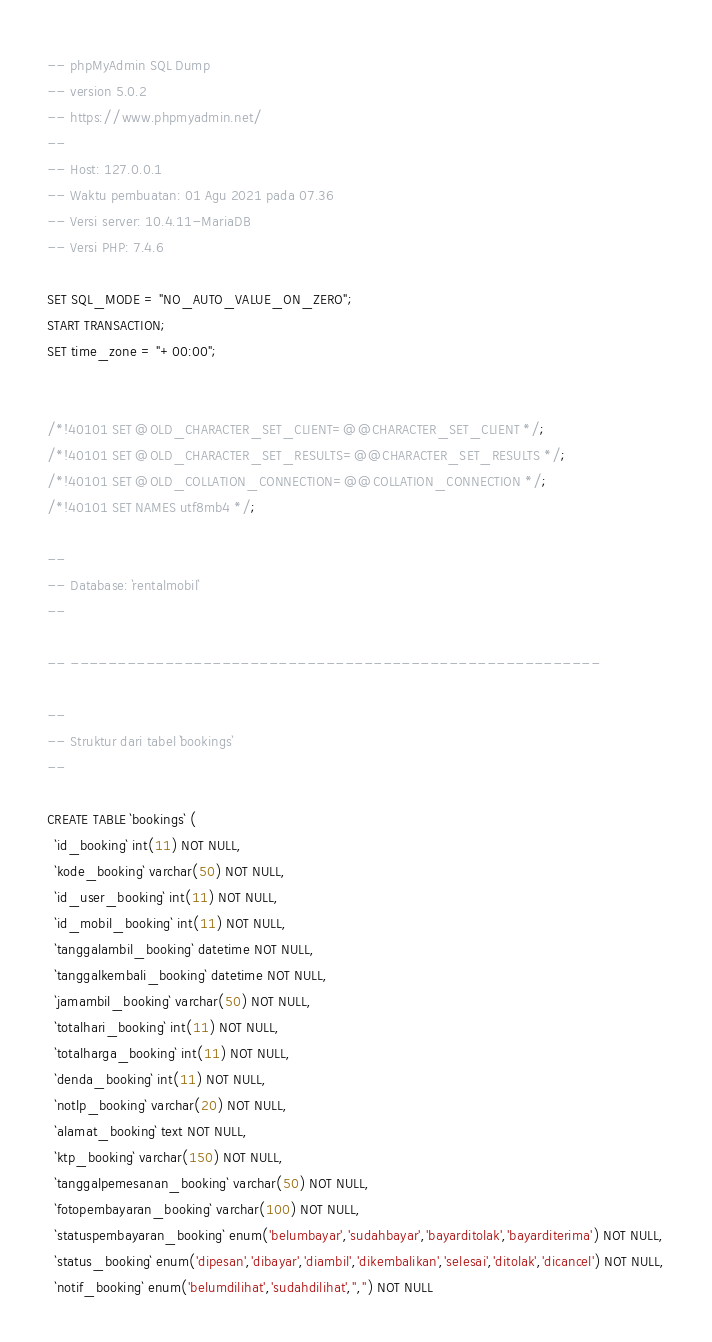Convert code to text. <code><loc_0><loc_0><loc_500><loc_500><_SQL_>-- phpMyAdmin SQL Dump
-- version 5.0.2
-- https://www.phpmyadmin.net/
--
-- Host: 127.0.0.1
-- Waktu pembuatan: 01 Agu 2021 pada 07.36
-- Versi server: 10.4.11-MariaDB
-- Versi PHP: 7.4.6

SET SQL_MODE = "NO_AUTO_VALUE_ON_ZERO";
START TRANSACTION;
SET time_zone = "+00:00";


/*!40101 SET @OLD_CHARACTER_SET_CLIENT=@@CHARACTER_SET_CLIENT */;
/*!40101 SET @OLD_CHARACTER_SET_RESULTS=@@CHARACTER_SET_RESULTS */;
/*!40101 SET @OLD_COLLATION_CONNECTION=@@COLLATION_CONNECTION */;
/*!40101 SET NAMES utf8mb4 */;

--
-- Database: `rentalmobil`
--

-- --------------------------------------------------------

--
-- Struktur dari tabel `bookings`
--

CREATE TABLE `bookings` (
  `id_booking` int(11) NOT NULL,
  `kode_booking` varchar(50) NOT NULL,
  `id_user_booking` int(11) NOT NULL,
  `id_mobil_booking` int(11) NOT NULL,
  `tanggalambil_booking` datetime NOT NULL,
  `tanggalkembali_booking` datetime NOT NULL,
  `jamambil_booking` varchar(50) NOT NULL,
  `totalhari_booking` int(11) NOT NULL,
  `totalharga_booking` int(11) NOT NULL,
  `denda_booking` int(11) NOT NULL,
  `notlp_booking` varchar(20) NOT NULL,
  `alamat_booking` text NOT NULL,
  `ktp_booking` varchar(150) NOT NULL,
  `tanggalpemesanan_booking` varchar(50) NOT NULL,
  `fotopembayaran_booking` varchar(100) NOT NULL,
  `statuspembayaran_booking` enum('belumbayar','sudahbayar','bayarditolak','bayarditerima') NOT NULL,
  `status_booking` enum('dipesan','dibayar','diambil','dikembalikan','selesai','ditolak','dicancel') NOT NULL,
  `notif_booking` enum('belumdilihat','sudahdilihat','','') NOT NULL</code> 